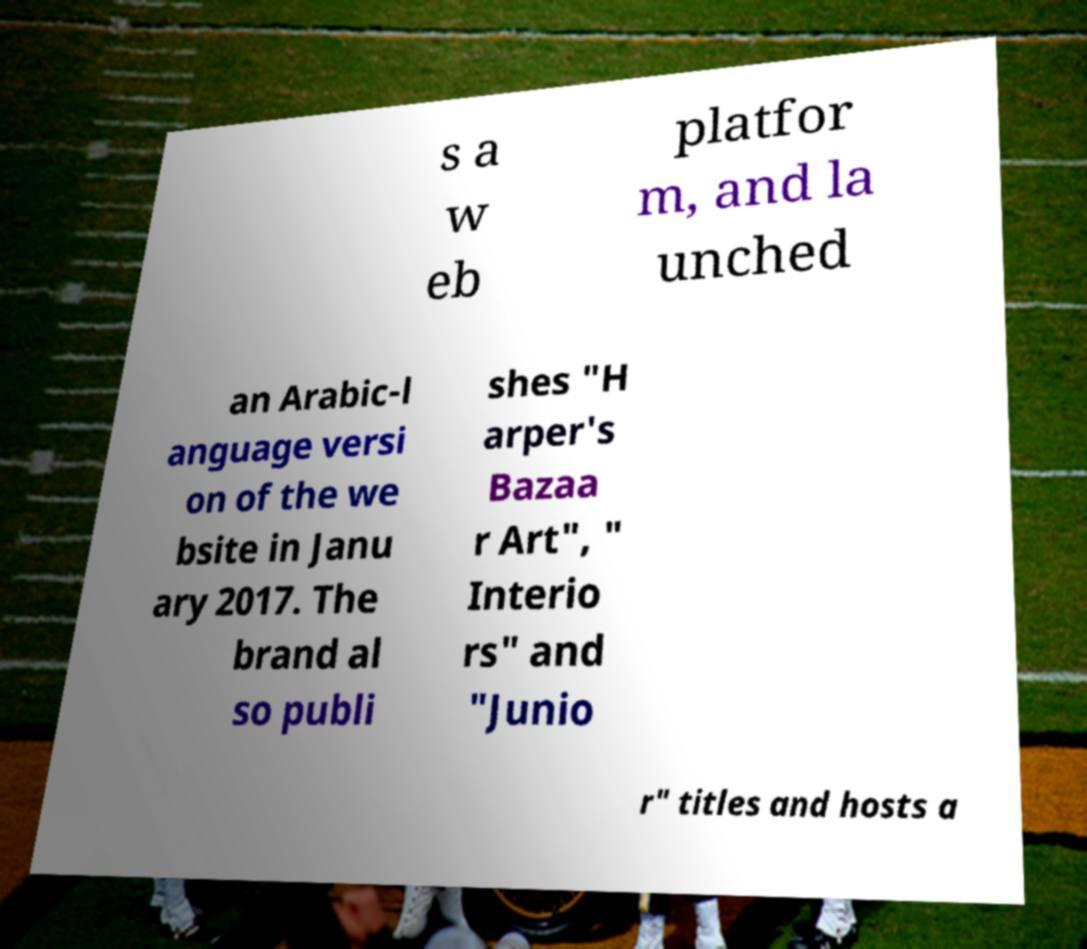I need the written content from this picture converted into text. Can you do that? s a w eb platfor m, and la unched an Arabic-l anguage versi on of the we bsite in Janu ary 2017. The brand al so publi shes "H arper's Bazaa r Art", " Interio rs" and "Junio r" titles and hosts a 